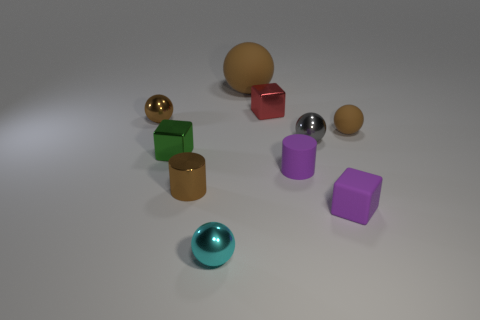Is there any other thing that has the same material as the large object?
Provide a succinct answer. Yes. There is a red thing that is the same shape as the small green object; what is it made of?
Offer a terse response. Metal. Are there fewer cyan metal objects behind the matte cube than gray things?
Offer a very short reply. Yes. Does the brown rubber object that is in front of the red shiny object have the same shape as the tiny cyan thing?
Offer a terse response. Yes. Is there anything else that is the same color as the rubber cube?
Make the answer very short. Yes. There is a brown cylinder that is the same material as the small red object; what size is it?
Provide a succinct answer. Small. There is a tiny cube that is in front of the tiny metallic block that is on the left side of the large brown ball left of the small matte cylinder; what is it made of?
Your answer should be compact. Rubber. Is the number of small gray metal things less than the number of big red cylinders?
Provide a succinct answer. No. Do the tiny purple block and the big brown object have the same material?
Make the answer very short. Yes. The tiny matte object that is the same color as the large rubber object is what shape?
Offer a very short reply. Sphere. 